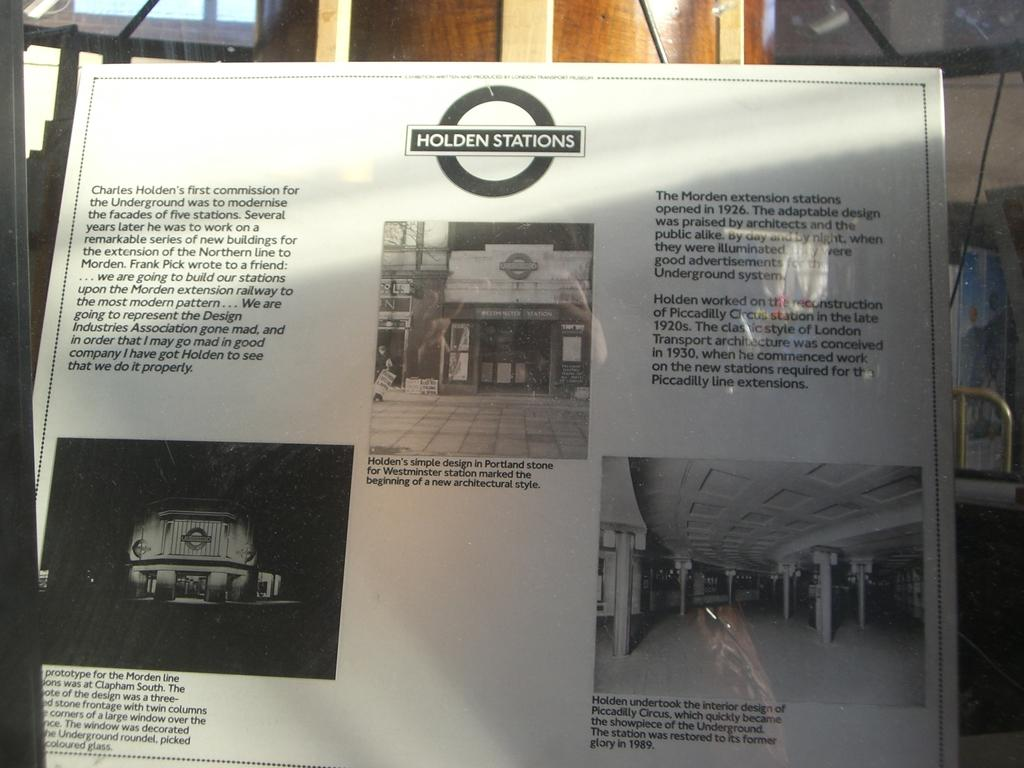<image>
Write a terse but informative summary of the picture. A sign for Holden Station is shown in black and white. 